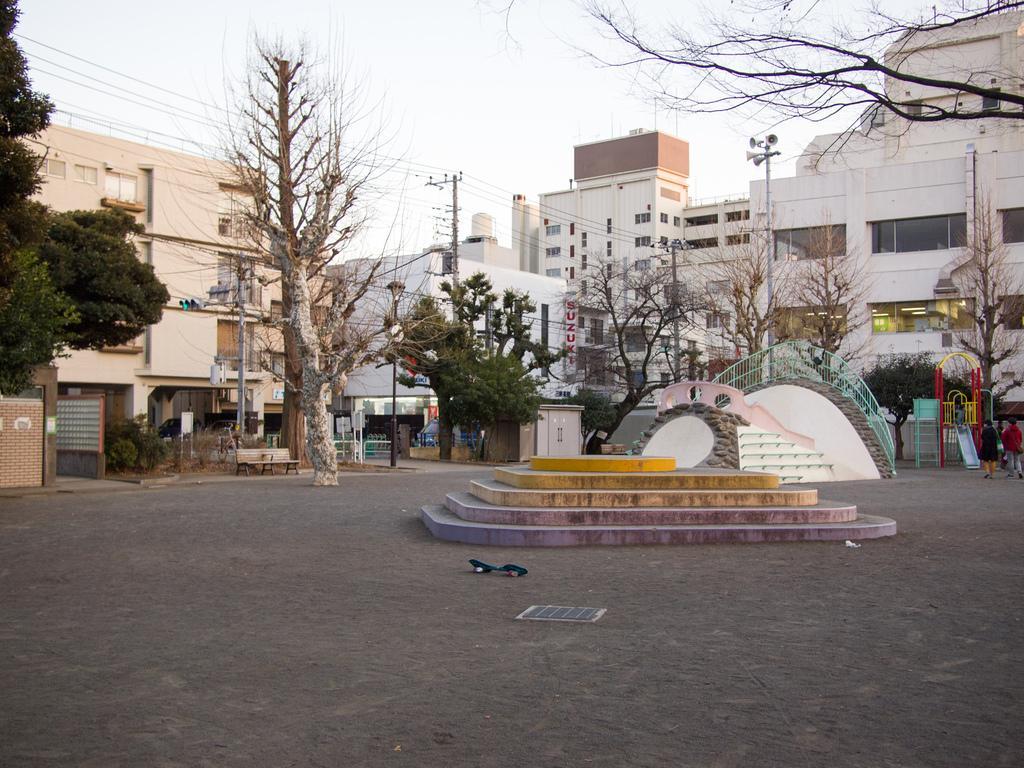In one or two sentences, can you explain what this image depicts? In this picture I can see many buildings, trees, electric poles and wires. On the right there is a speaker on the top of the pole. Beside that I can see some children playing instruments. In the center I can see the stairs. At the top there is a sky. On the left I can see the bench, sign board, traffic signals and plants. 